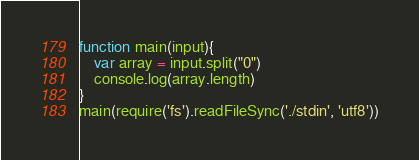Convert code to text. <code><loc_0><loc_0><loc_500><loc_500><_JavaScript_>function main(input){
    var array = input.split("0")
    console.log(array.length)
}
main(require('fs').readFileSync('./stdin', 'utf8'))
</code> 